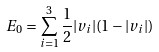<formula> <loc_0><loc_0><loc_500><loc_500>E _ { 0 } = \sum _ { i = 1 } ^ { 3 } \frac { 1 } { 2 } | v _ { i } | ( 1 - | v _ { i } | )</formula> 